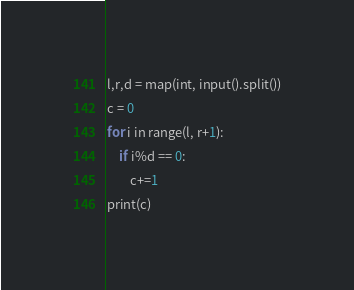Convert code to text. <code><loc_0><loc_0><loc_500><loc_500><_Python_>l,r,d = map(int, input().split())
c = 0
for i in range(l, r+1):
    if i%d == 0:
        c+=1
print(c)
</code> 